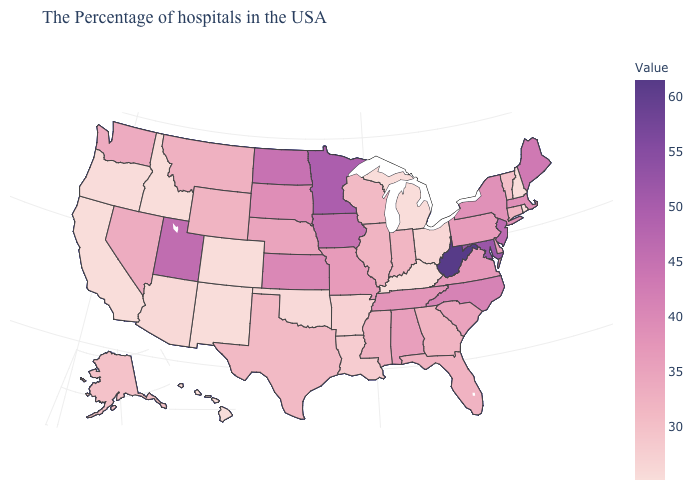Which states have the lowest value in the Northeast?
Short answer required. Rhode Island, New Hampshire. Does the map have missing data?
Be succinct. No. Does Hawaii have the lowest value in the USA?
Quick response, please. Yes. Which states have the lowest value in the West?
Concise answer only. Colorado, New Mexico, Idaho, California, Hawaii. 